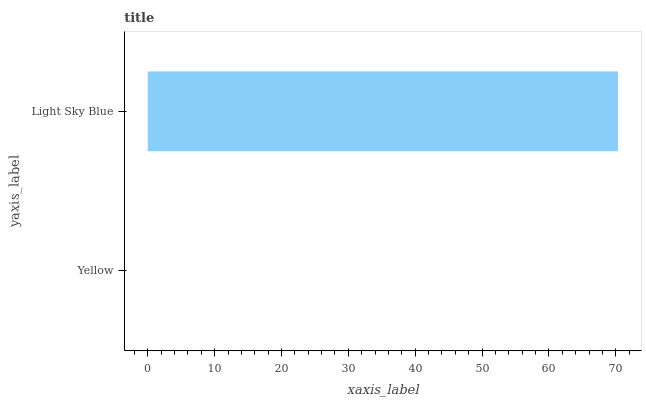Is Yellow the minimum?
Answer yes or no. Yes. Is Light Sky Blue the maximum?
Answer yes or no. Yes. Is Light Sky Blue the minimum?
Answer yes or no. No. Is Light Sky Blue greater than Yellow?
Answer yes or no. Yes. Is Yellow less than Light Sky Blue?
Answer yes or no. Yes. Is Yellow greater than Light Sky Blue?
Answer yes or no. No. Is Light Sky Blue less than Yellow?
Answer yes or no. No. Is Light Sky Blue the high median?
Answer yes or no. Yes. Is Yellow the low median?
Answer yes or no. Yes. Is Yellow the high median?
Answer yes or no. No. Is Light Sky Blue the low median?
Answer yes or no. No. 